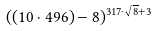Convert formula to latex. <formula><loc_0><loc_0><loc_500><loc_500>( ( 1 0 \cdot 4 9 6 ) - 8 ) ^ { 3 1 7 \cdot \sqrt { 8 } + 3 }</formula> 